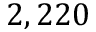Convert formula to latex. <formula><loc_0><loc_0><loc_500><loc_500>2 , 2 2 0</formula> 